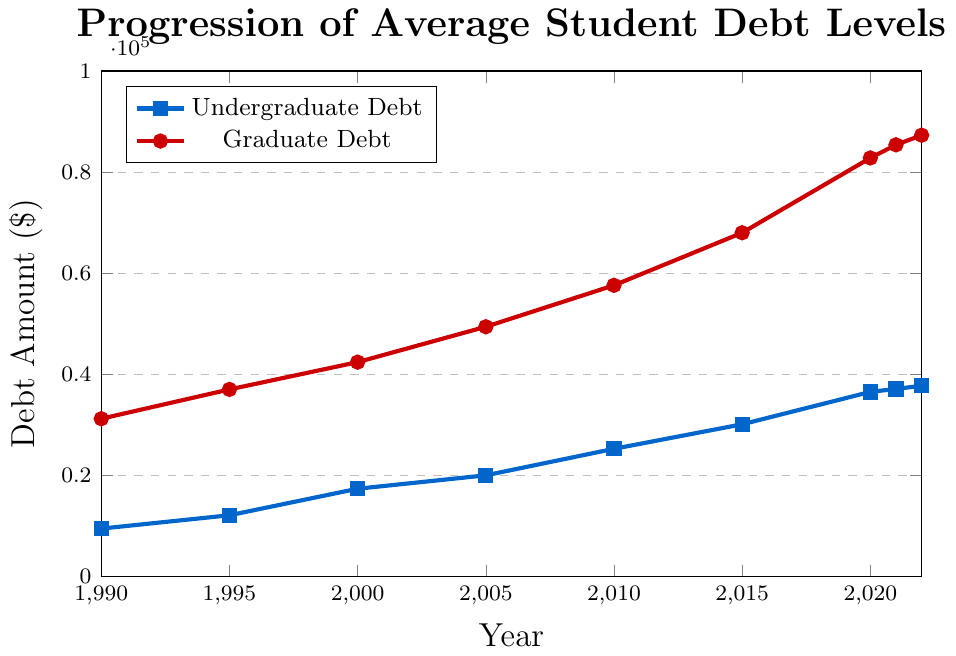What's the year with the highest undergraduate debt? Look for the highest point on the undergraduate debt line (blue). The highest point occurs in 2022, where the debt level is $37,720.
Answer: 2022 How much did the graduate debt level increase from 1990 to 2022? Subtract the debt level in 1990 from the debt level in 2022 for graduate students. The values are $87,300 (2022) and $31,200 (1990). The difference is $87,300 - $31,200 = $56,100.
Answer: $56,100 Compare the undergraduate debt in 2010 with the graduate debt in 1990. Which is higher? Refer to the 2010 undergraduate and 1990 graduate debt levels. For 2010 undergraduates, it's $25,250. For 1990 graduates, it's $31,200. Since $31,200 is higher than $25,250, the graduate debt in 1990 is higher.
Answer: Graduate debt in 1990 What is the average undergraduate debt level in 2000 and 2005? Add the undergraduate debt in 2000 ($17,350) and 2005 ($20,000), then divide by 2. The sum is $17,350 + $20,000 = $37,350, so the average is $37,350 / 2 = $18,675.
Answer: $18,675 How did the undergraduate debt change between 2020 and 2021? Subtract the undergraduate debt in 2020 from the debt in 2021. The values are $37,100 (2021) and $36,510 (2020). The difference is $37,100 - $36,510 = $590, showing an increase of $590.
Answer: Increased by $590 What color represents the graduate debt in the figure? Identify the color used for the graduate debt line in the figure. The graduate debt is marked with a red line.
Answer: Red Which year shows a larger increase in undergraduate debt from the previous year, 2000 to 2005 or 2015 to 2020? Calculate the increase for both intervals. From 2000 to 2005: $20,000 - $17,350 = $2,650. From 2015 to 2020: $36,510 - $30,100 = $6,410. The larger increase is from 2015 to 2020.
Answer: 2015 to 2020 What is the ratio of graduate debt to undergraduate debt in 2022? Divide the graduate debt by the undergraduate debt for 2022. The values are $87,300 (graduate) and $37,720 (undergraduate). The ratio is $87,300 / $37,720 ≈ 2.31.
Answer: Approximately 2.31 In which period did the graduate debt increase the most—the 1990s, 2000s, or 2010s? Calculate the increase for each decade by comparing the first and last years of each period. 1990s: $37,000 - $31,200 = $5,800. 2000s: $57,600 - $42,400 = $15,200. 2010s: $82,800 - $57,600 = $25,200. The highest increase occurred in the 2010s.
Answer: 2010s 